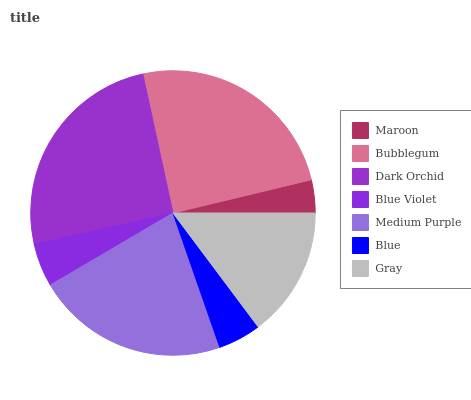Is Maroon the minimum?
Answer yes or no. Yes. Is Dark Orchid the maximum?
Answer yes or no. Yes. Is Bubblegum the minimum?
Answer yes or no. No. Is Bubblegum the maximum?
Answer yes or no. No. Is Bubblegum greater than Maroon?
Answer yes or no. Yes. Is Maroon less than Bubblegum?
Answer yes or no. Yes. Is Maroon greater than Bubblegum?
Answer yes or no. No. Is Bubblegum less than Maroon?
Answer yes or no. No. Is Gray the high median?
Answer yes or no. Yes. Is Gray the low median?
Answer yes or no. Yes. Is Blue Violet the high median?
Answer yes or no. No. Is Bubblegum the low median?
Answer yes or no. No. 